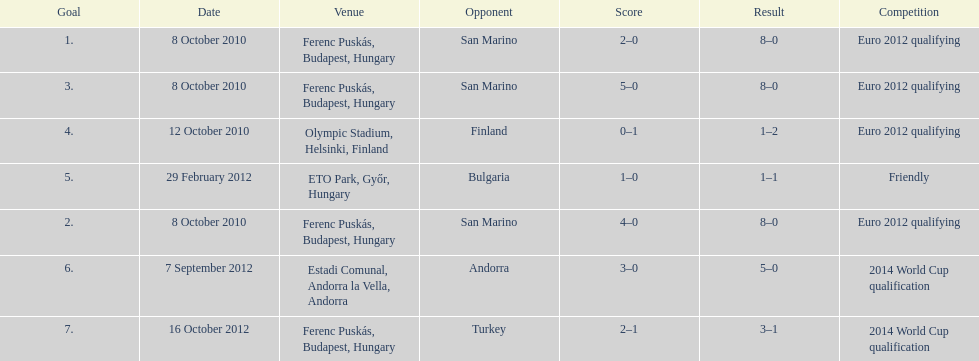What is the total number of international goals ádám szalai has made? 7. 